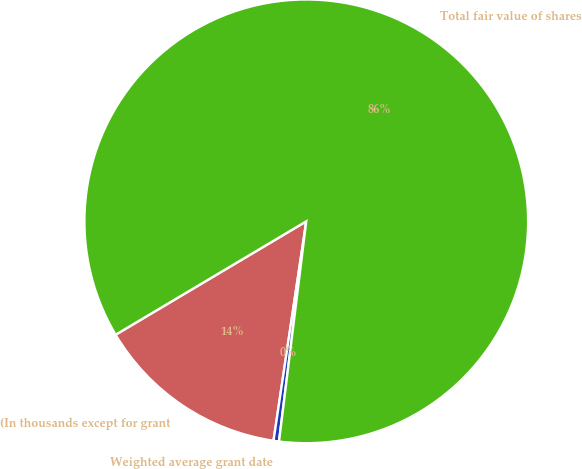Convert chart. <chart><loc_0><loc_0><loc_500><loc_500><pie_chart><fcel>(In thousands except for grant<fcel>Weighted average grant date<fcel>Total fair value of shares<nl><fcel>14.1%<fcel>0.4%<fcel>85.5%<nl></chart> 